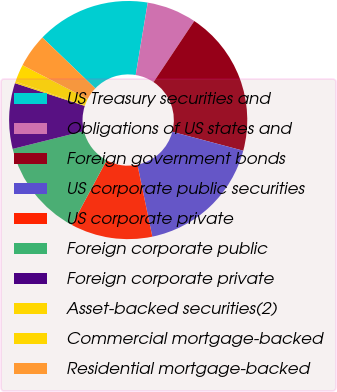<chart> <loc_0><loc_0><loc_500><loc_500><pie_chart><fcel>US Treasury securities and<fcel>Obligations of US states and<fcel>Foreign government bonds<fcel>US corporate public securities<fcel>US corporate private<fcel>Foreign corporate public<fcel>Foreign corporate private<fcel>Asset-backed securities(2)<fcel>Commercial mortgage-backed<fcel>Residential mortgage-backed<nl><fcel>15.43%<fcel>6.74%<fcel>19.78%<fcel>17.61%<fcel>11.09%<fcel>13.26%<fcel>8.91%<fcel>0.22%<fcel>2.39%<fcel>4.57%<nl></chart> 